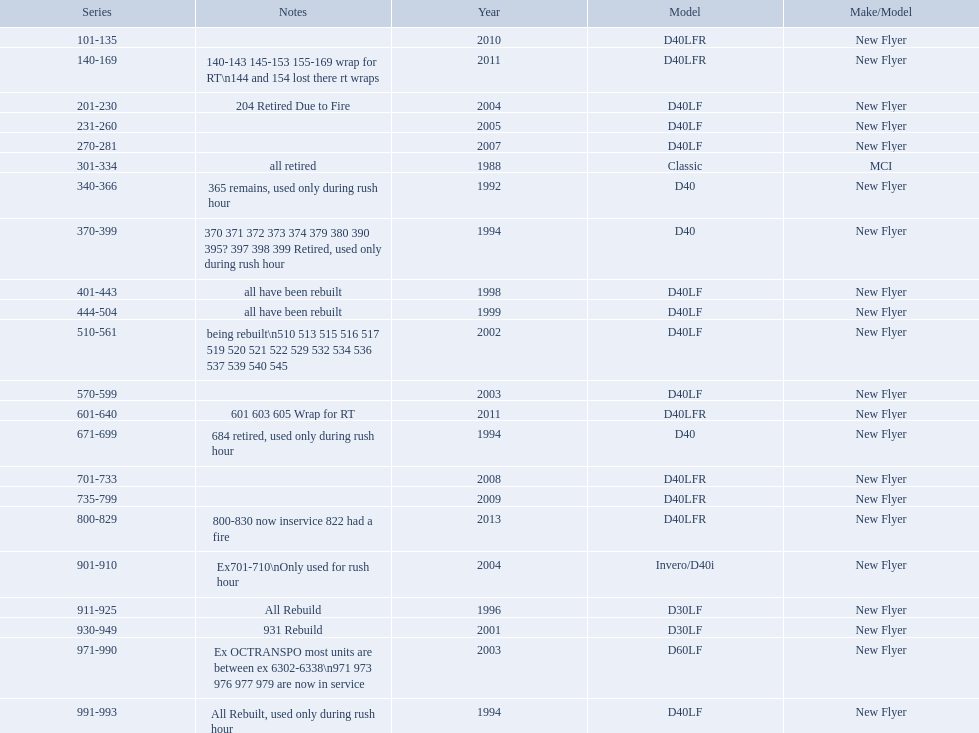What are all the models of buses? D40LFR, D40LF, Classic, D40, Invero/D40i, D30LF, D60LF. Of these buses, which series is the oldest? 301-334. Which is the  newest? 800-829. 